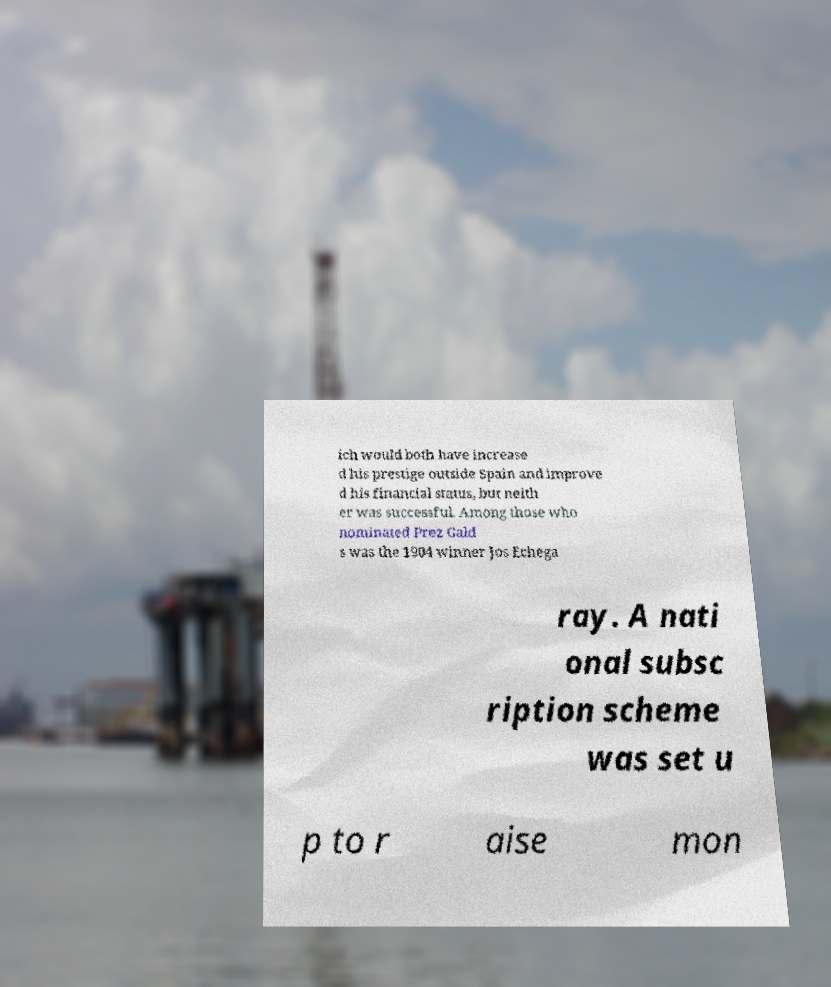Can you accurately transcribe the text from the provided image for me? ich would both have increase d his prestige outside Spain and improve d his financial status, but neith er was successful. Among those who nominated Prez Gald s was the 1904 winner Jos Echega ray. A nati onal subsc ription scheme was set u p to r aise mon 